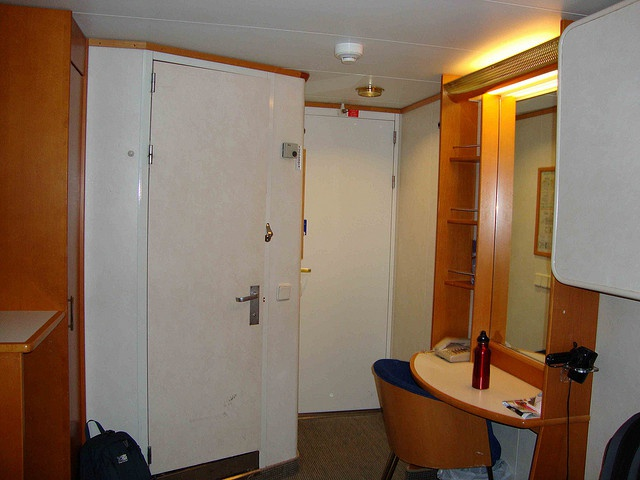Describe the objects in this image and their specific colors. I can see chair in black, maroon, and gray tones, backpack in black and gray tones, suitcase in black and gray tones, chair in black, gray, maroon, and purple tones, and hair drier in black, maroon, and gray tones in this image. 